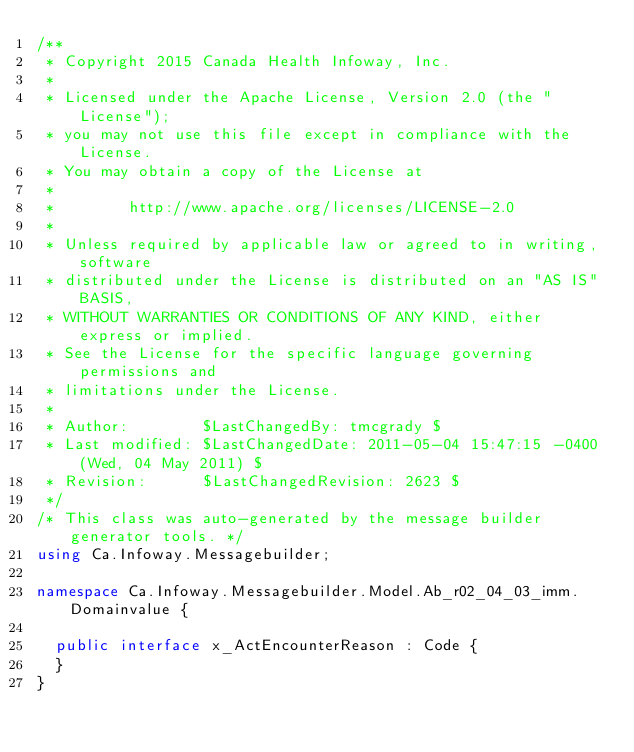Convert code to text. <code><loc_0><loc_0><loc_500><loc_500><_C#_>/**
 * Copyright 2015 Canada Health Infoway, Inc.
 *
 * Licensed under the Apache License, Version 2.0 (the "License");
 * you may not use this file except in compliance with the License.
 * You may obtain a copy of the License at
 *
 *        http://www.apache.org/licenses/LICENSE-2.0
 *
 * Unless required by applicable law or agreed to in writing, software
 * distributed under the License is distributed on an "AS IS" BASIS,
 * WITHOUT WARRANTIES OR CONDITIONS OF ANY KIND, either express or implied.
 * See the License for the specific language governing permissions and
 * limitations under the License.
 *
 * Author:        $LastChangedBy: tmcgrady $
 * Last modified: $LastChangedDate: 2011-05-04 15:47:15 -0400 (Wed, 04 May 2011) $
 * Revision:      $LastChangedRevision: 2623 $
 */
/* This class was auto-generated by the message builder generator tools. */
using Ca.Infoway.Messagebuilder;

namespace Ca.Infoway.Messagebuilder.Model.Ab_r02_04_03_imm.Domainvalue {

  public interface x_ActEncounterReason : Code {
  }
}
</code> 